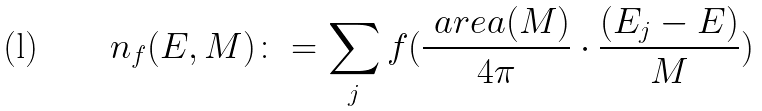<formula> <loc_0><loc_0><loc_500><loc_500>n _ { f } ( E , \L M ) \colon = \sum _ { j } f ( \frac { \ a r e a ( M ) } { 4 \pi } \cdot \frac { ( E _ { j } - E ) } { \L M } )</formula> 